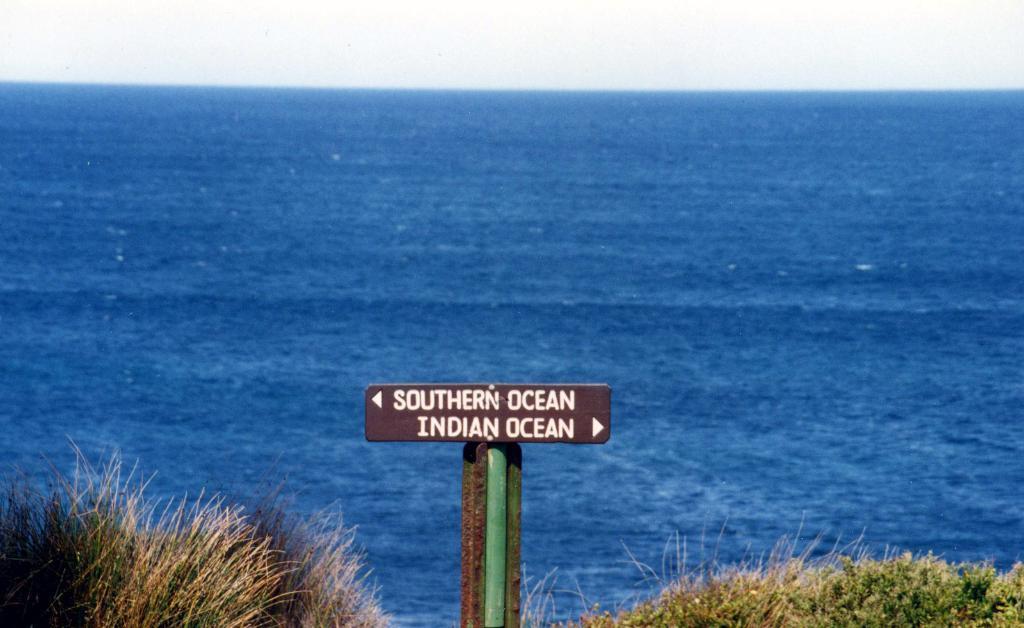In one or two sentences, can you explain what this image depicts? There is a board which has southern ocean and Indian ocean written on it and there are water in the background. 